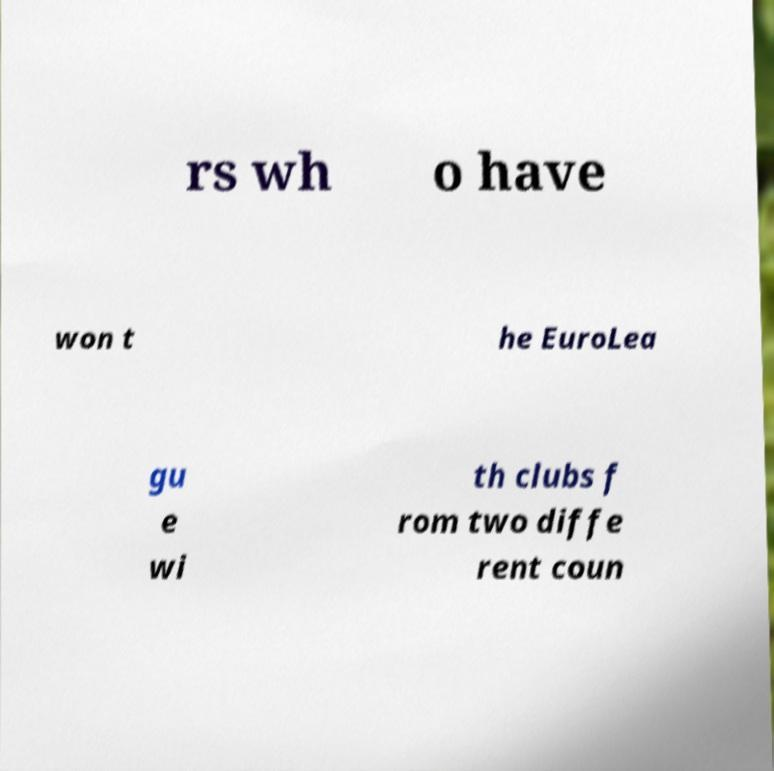Can you read and provide the text displayed in the image?This photo seems to have some interesting text. Can you extract and type it out for me? rs wh o have won t he EuroLea gu e wi th clubs f rom two diffe rent coun 